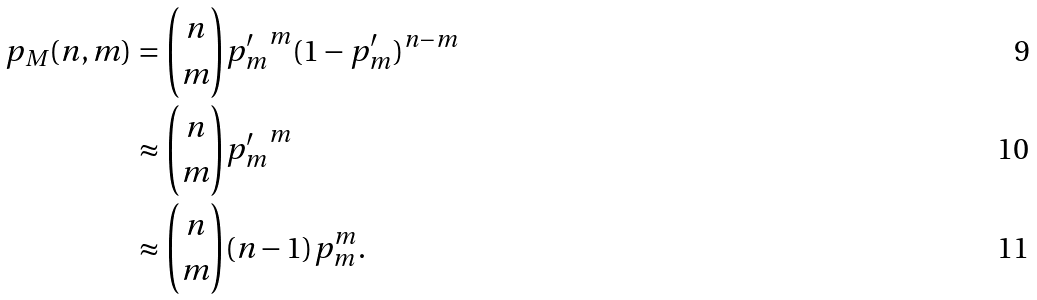<formula> <loc_0><loc_0><loc_500><loc_500>p _ { M } ( n , m ) & = \binom { n } { m } { p ^ { \prime } _ { m } } ^ { m } ( 1 - p ^ { \prime } _ { m } ) ^ { n - m } \\ & \approx \binom { n } { m } { p ^ { \prime } _ { m } } ^ { m } \\ & \approx \binom { n } { m } ( n - 1 ) p _ { m } ^ { m } .</formula> 